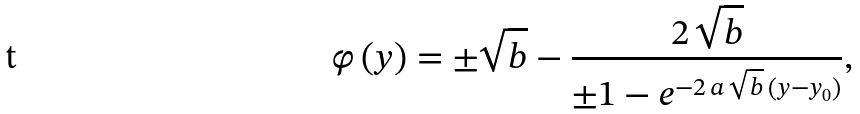<formula> <loc_0><loc_0><loc_500><loc_500>\varphi \left ( y \right ) = \pm \sqrt { b } - \frac { 2 \, \sqrt { b } } { \pm 1 - e ^ { - 2 \, a \, \sqrt { b } \, \left ( y - y _ { 0 } \right ) } } ,</formula> 